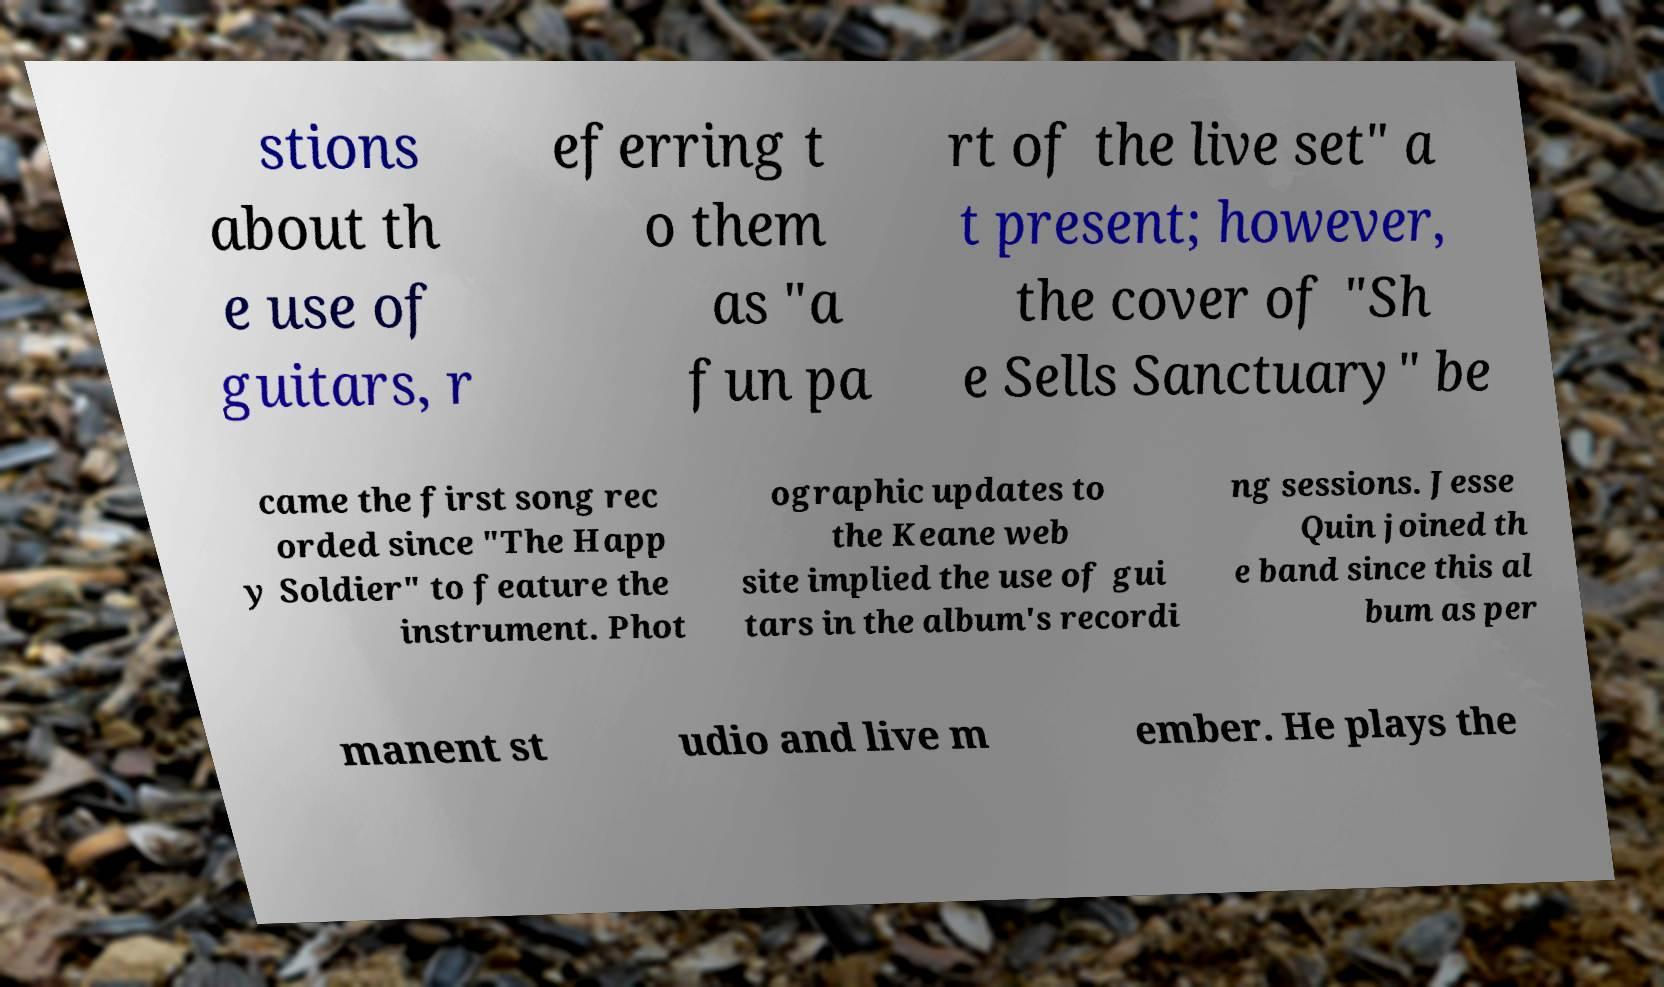What messages or text are displayed in this image? I need them in a readable, typed format. stions about th e use of guitars, r eferring t o them as "a fun pa rt of the live set" a t present; however, the cover of "Sh e Sells Sanctuary" be came the first song rec orded since "The Happ y Soldier" to feature the instrument. Phot ographic updates to the Keane web site implied the use of gui tars in the album's recordi ng sessions. Jesse Quin joined th e band since this al bum as per manent st udio and live m ember. He plays the 